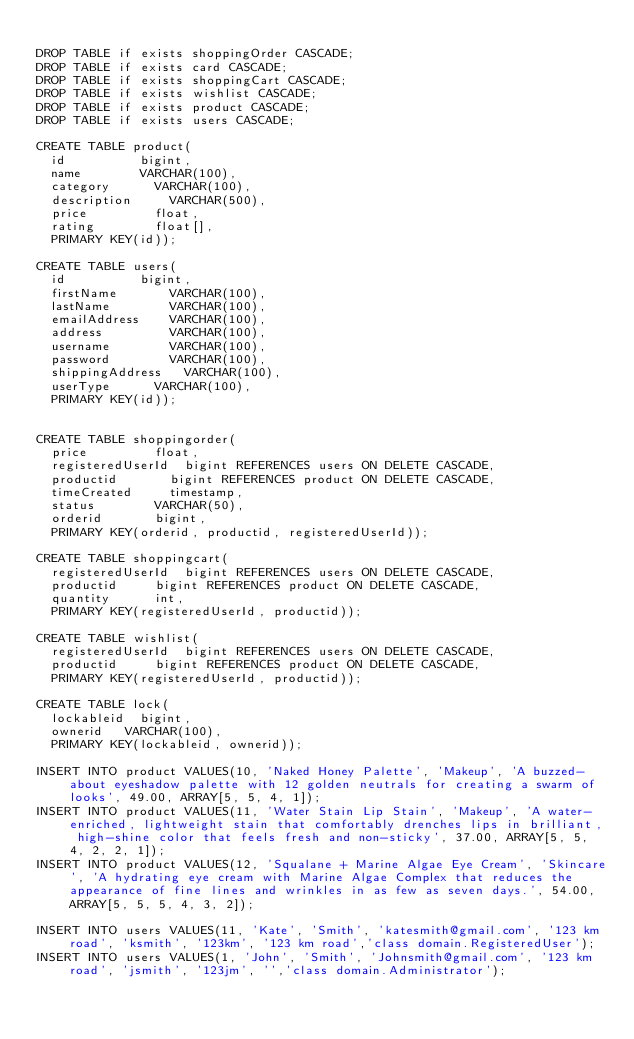Convert code to text. <code><loc_0><loc_0><loc_500><loc_500><_SQL_>
DROP TABLE if exists shoppingOrder CASCADE;
DROP TABLE if exists card CASCADE;
DROP TABLE if exists shoppingCart CASCADE;
DROP TABLE if exists wishlist CASCADE;
DROP TABLE if exists product CASCADE;
DROP TABLE if exists users CASCADE;

CREATE TABLE product(
	id 					bigint,
	name 				VARCHAR(100),
	category 			VARCHAR(100),
	description 		VARCHAR(500),
	price 				float,
	rating				float[],
	PRIMARY KEY(id));
	
CREATE TABLE users(
	id					bigint,
	firstName   		VARCHAR(100),
	lastName    		VARCHAR(100),
	emailAddress 		VARCHAR(100),
	address      		VARCHAR(100),
	username     		VARCHAR(100),
	password     		VARCHAR(100),
	shippingAddress 	VARCHAR(100),
	userType			VARCHAR(100),
	PRIMARY KEY(id));
	

CREATE TABLE shoppingorder(
	price 				float,
	registeredUserId 	bigint REFERENCES users ON DELETE CASCADE,
	productid 			bigint REFERENCES product ON DELETE CASCADE,
	timeCreated 		timestamp,
	status				VARCHAR(50),
	orderid				bigint,
	PRIMARY KEY(orderid, productid, registeredUserId));

CREATE TABLE shoppingcart(
	registeredUserId 	bigint REFERENCES users ON DELETE CASCADE,
	productid			bigint REFERENCES product ON DELETE CASCADE,
	quantity			int,
	PRIMARY KEY(registeredUserId, productid));
	
CREATE TABLE wishlist(
	registeredUserId 	bigint REFERENCES users ON DELETE CASCADE,
	productid			bigint REFERENCES product ON DELETE CASCADE,
	PRIMARY KEY(registeredUserId, productid));
	
CREATE TABLE lock(
	lockableid	bigint,
	ownerid		VARCHAR(100),
	PRIMARY KEY(lockableid, ownerid));
	
INSERT INTO product VALUES(10, 'Naked Honey Palette', 'Makeup', 'A buzzed-about eyeshadow palette with 12 golden neutrals for creating a swarm of looks', 49.00, ARRAY[5, 5, 4, 1]);
INSERT INTO product VALUES(11, 'Water Stain Lip Stain', 'Makeup', 'A water-enriched, lightweight stain that comfortably drenches lips in brilliant, high-shine color that feels fresh and non-sticky', 37.00, ARRAY[5, 5, 4, 2, 2, 1]);
INSERT INTO product VALUES(12, 'Squalane + Marine Algae Eye Cream', 'Skincare', 'A hydrating eye cream with Marine Algae Complex that reduces the appearance of fine lines and wrinkles in as few as seven days.', 54.00, ARRAY[5, 5, 5, 4, 3, 2]);

INSERT INTO users VALUES(11, 'Kate', 'Smith', 'katesmith@gmail.com', '123 km road', 'ksmith', '123km', '123 km road','class domain.RegisteredUser');
INSERT INTO users VALUES(1, 'John', 'Smith', 'Johnsmith@gmail.com', '123 km road', 'jsmith', '123jm', '','class domain.Administrator');





</code> 